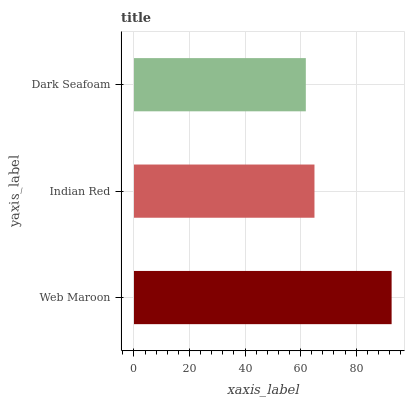Is Dark Seafoam the minimum?
Answer yes or no. Yes. Is Web Maroon the maximum?
Answer yes or no. Yes. Is Indian Red the minimum?
Answer yes or no. No. Is Indian Red the maximum?
Answer yes or no. No. Is Web Maroon greater than Indian Red?
Answer yes or no. Yes. Is Indian Red less than Web Maroon?
Answer yes or no. Yes. Is Indian Red greater than Web Maroon?
Answer yes or no. No. Is Web Maroon less than Indian Red?
Answer yes or no. No. Is Indian Red the high median?
Answer yes or no. Yes. Is Indian Red the low median?
Answer yes or no. Yes. Is Web Maroon the high median?
Answer yes or no. No. Is Dark Seafoam the low median?
Answer yes or no. No. 